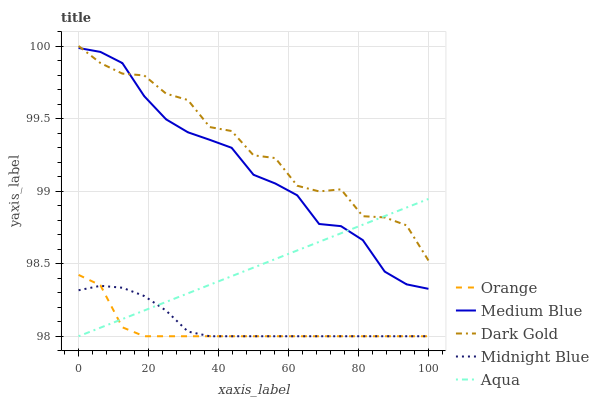Does Orange have the minimum area under the curve?
Answer yes or no. Yes. Does Dark Gold have the maximum area under the curve?
Answer yes or no. Yes. Does Aqua have the minimum area under the curve?
Answer yes or no. No. Does Aqua have the maximum area under the curve?
Answer yes or no. No. Is Aqua the smoothest?
Answer yes or no. Yes. Is Dark Gold the roughest?
Answer yes or no. Yes. Is Medium Blue the smoothest?
Answer yes or no. No. Is Medium Blue the roughest?
Answer yes or no. No. Does Orange have the lowest value?
Answer yes or no. Yes. Does Medium Blue have the lowest value?
Answer yes or no. No. Does Dark Gold have the highest value?
Answer yes or no. Yes. Does Aqua have the highest value?
Answer yes or no. No. Is Midnight Blue less than Dark Gold?
Answer yes or no. Yes. Is Medium Blue greater than Orange?
Answer yes or no. Yes. Does Medium Blue intersect Aqua?
Answer yes or no. Yes. Is Medium Blue less than Aqua?
Answer yes or no. No. Is Medium Blue greater than Aqua?
Answer yes or no. No. Does Midnight Blue intersect Dark Gold?
Answer yes or no. No. 